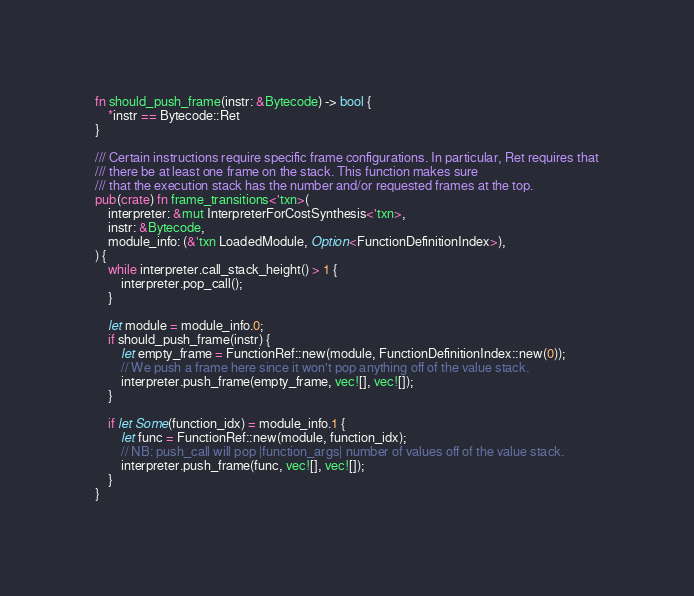<code> <loc_0><loc_0><loc_500><loc_500><_Rust_>fn should_push_frame(instr: &Bytecode) -> bool {
    *instr == Bytecode::Ret
}

/// Certain instructions require specific frame configurations. In particular, Ret requires that
/// there be at least one frame on the stack. This function makes sure
/// that the execution stack has the number and/or requested frames at the top.
pub(crate) fn frame_transitions<'txn>(
    interpreter: &mut InterpreterForCostSynthesis<'txn>,
    instr: &Bytecode,
    module_info: (&'txn LoadedModule, Option<FunctionDefinitionIndex>),
) {
    while interpreter.call_stack_height() > 1 {
        interpreter.pop_call();
    }

    let module = module_info.0;
    if should_push_frame(instr) {
        let empty_frame = FunctionRef::new(module, FunctionDefinitionIndex::new(0));
        // We push a frame here since it won't pop anything off of the value stack.
        interpreter.push_frame(empty_frame, vec![], vec![]);
    }

    if let Some(function_idx) = module_info.1 {
        let func = FunctionRef::new(module, function_idx);
        // NB: push_call will pop |function_args| number of values off of the value stack.
        interpreter.push_frame(func, vec![], vec![]);
    }
}
</code> 